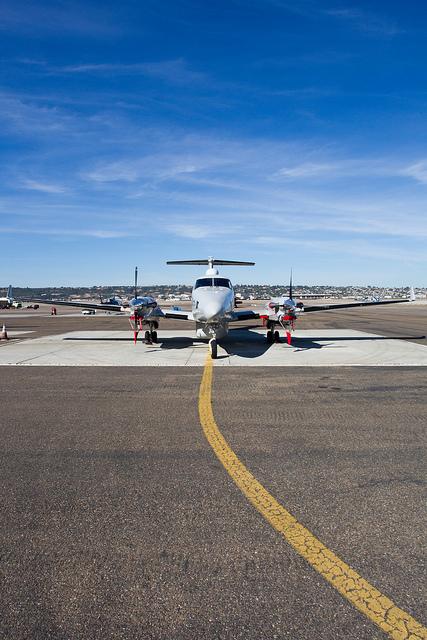Is the plane in the air?
Answer briefly. No. How many engines on the plane?
Quick response, please. 2. What does the yellow line signify?
Write a very short answer. Runway. 